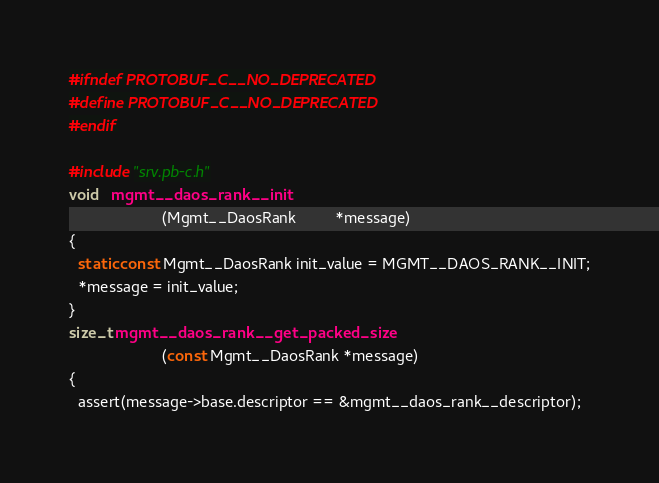<code> <loc_0><loc_0><loc_500><loc_500><_C_>#ifndef PROTOBUF_C__NO_DEPRECATED
#define PROTOBUF_C__NO_DEPRECATED
#endif

#include "srv.pb-c.h"
void   mgmt__daos_rank__init
                     (Mgmt__DaosRank         *message)
{
  static const Mgmt__DaosRank init_value = MGMT__DAOS_RANK__INIT;
  *message = init_value;
}
size_t mgmt__daos_rank__get_packed_size
                     (const Mgmt__DaosRank *message)
{
  assert(message->base.descriptor == &mgmt__daos_rank__descriptor);</code> 